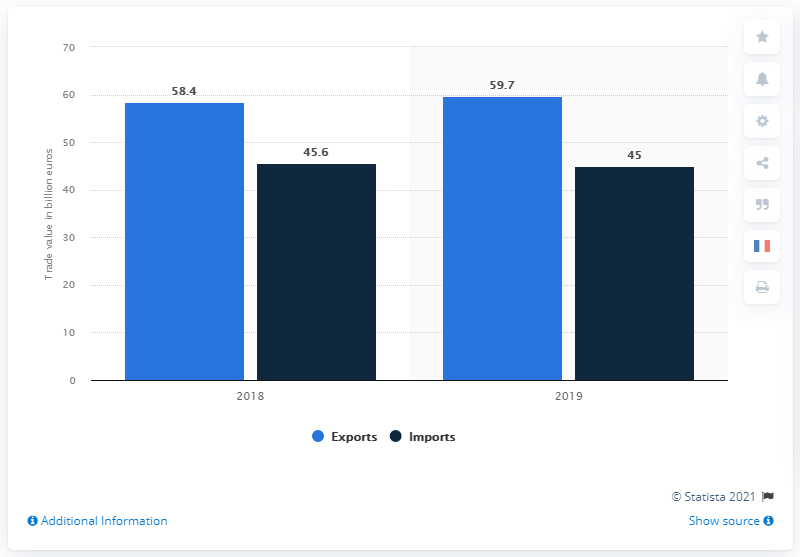How does the balance between exports and imports of chemicals, cosmetics, and perfumes look for France in 2019? In 2019, France had a positive balance in the trade of chemicals, cosmetics, and perfumes, with exports totaling 59.7 billion US dollars and imports at 45 billion US dollars. This indicates a robust surplus in this sector. 